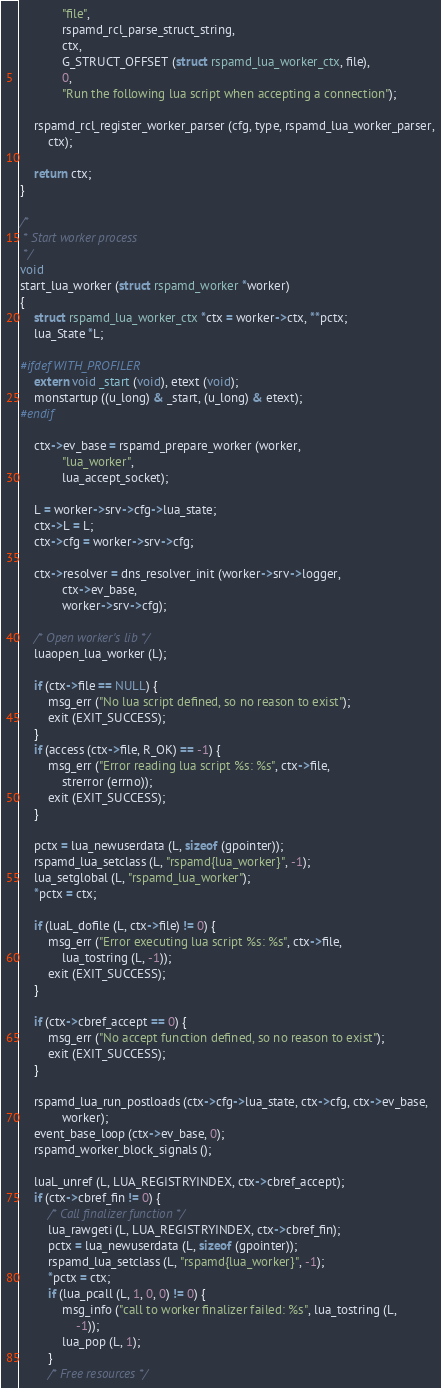Convert code to text. <code><loc_0><loc_0><loc_500><loc_500><_C_>			"file",
			rspamd_rcl_parse_struct_string,
			ctx,
			G_STRUCT_OFFSET (struct rspamd_lua_worker_ctx, file),
			0,
			"Run the following lua script when accepting a connection");

	rspamd_rcl_register_worker_parser (cfg, type, rspamd_lua_worker_parser,
		ctx);

	return ctx;
}

/*
 * Start worker process
 */
void
start_lua_worker (struct rspamd_worker *worker)
{
	struct rspamd_lua_worker_ctx *ctx = worker->ctx, **pctx;
	lua_State *L;

#ifdef WITH_PROFILER
	extern void _start (void), etext (void);
	monstartup ((u_long) & _start, (u_long) & etext);
#endif

	ctx->ev_base = rspamd_prepare_worker (worker,
			"lua_worker",
			lua_accept_socket);

	L = worker->srv->cfg->lua_state;
	ctx->L = L;
	ctx->cfg = worker->srv->cfg;

	ctx->resolver = dns_resolver_init (worker->srv->logger,
			ctx->ev_base,
			worker->srv->cfg);

	/* Open worker's lib */
	luaopen_lua_worker (L);

	if (ctx->file == NULL) {
		msg_err ("No lua script defined, so no reason to exist");
		exit (EXIT_SUCCESS);
	}
	if (access (ctx->file, R_OK) == -1) {
		msg_err ("Error reading lua script %s: %s", ctx->file,
			strerror (errno));
		exit (EXIT_SUCCESS);
	}

	pctx = lua_newuserdata (L, sizeof (gpointer));
	rspamd_lua_setclass (L, "rspamd{lua_worker}", -1);
	lua_setglobal (L, "rspamd_lua_worker");
	*pctx = ctx;

	if (luaL_dofile (L, ctx->file) != 0) {
		msg_err ("Error executing lua script %s: %s", ctx->file,
			lua_tostring (L, -1));
		exit (EXIT_SUCCESS);
	}

	if (ctx->cbref_accept == 0) {
		msg_err ("No accept function defined, so no reason to exist");
		exit (EXIT_SUCCESS);
	}

	rspamd_lua_run_postloads (ctx->cfg->lua_state, ctx->cfg, ctx->ev_base,
			worker);
	event_base_loop (ctx->ev_base, 0);
	rspamd_worker_block_signals ();

	luaL_unref (L, LUA_REGISTRYINDEX, ctx->cbref_accept);
	if (ctx->cbref_fin != 0) {
		/* Call finalizer function */
		lua_rawgeti (L, LUA_REGISTRYINDEX, ctx->cbref_fin);
		pctx = lua_newuserdata (L, sizeof (gpointer));
		rspamd_lua_setclass (L, "rspamd{lua_worker}", -1);
		*pctx = ctx;
		if (lua_pcall (L, 1, 0, 0) != 0) {
			msg_info ("call to worker finalizer failed: %s", lua_tostring (L,
				-1));
			lua_pop (L, 1);
		}
		/* Free resources */</code> 